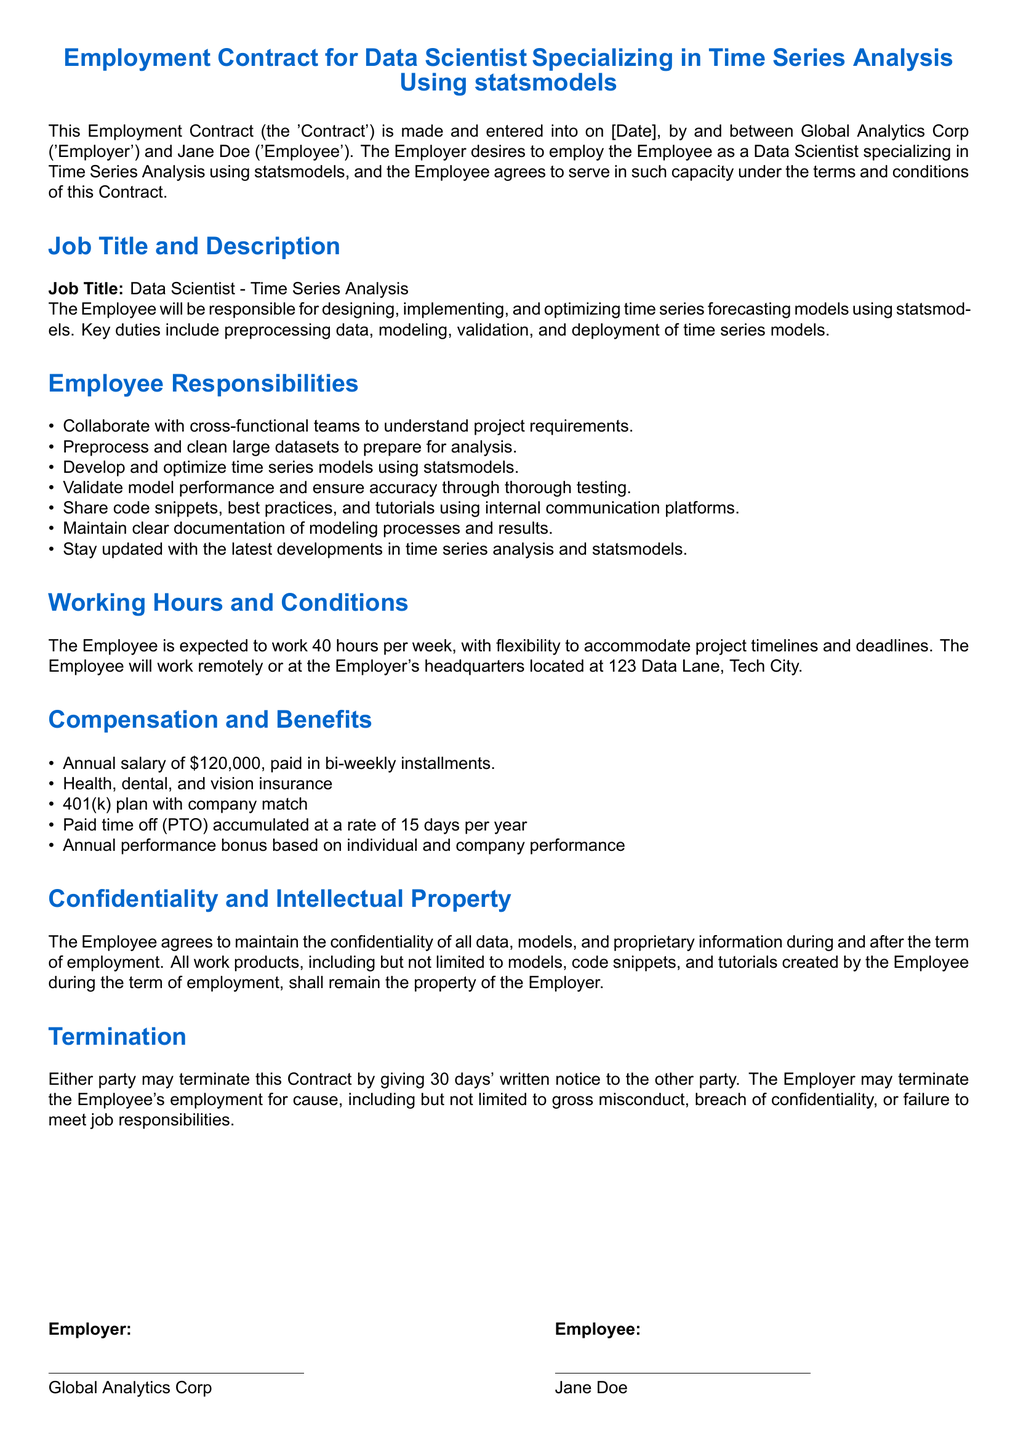What is the job title? The job title mentioned in the document is the specific position the Employee is being hired for, which is Data Scientist - Time Series Analysis.
Answer: Data Scientist - Time Series Analysis What is the annual salary? The annual salary is explicitly stated in the document as part of the compensation and benefits section.
Answer: $120,000 What are the expected working hours per week? This information can be found under the working hours and conditions section where it defines the Employee's expected work schedule.
Answer: 40 hours What is the notice period for termination? The termination section outlines the notice period required for either party to end the contract.
Answer: 30 days What type of insurance is provided? The compensation and benefits section lists various benefits, including health, dental, and vision insurance, as part of the offered package.
Answer: Health, dental, and vision insurance Which software library is the Employee expected to specialize in? The document specifies that the Employee should specialize in a particular library related to time series analysis.
Answer: statsmodels What is a key responsibility of the Employee? The responsibilities section outlines various tasks, one of which involves developing time series models.
Answer: Develop and optimize time series models What benefits accumulate at a rate of 15 days per year? This detail is presented in the compensation and benefits section regarding time off entitlement for the Employee.
Answer: Paid time off (PTO) What happens to the work products created by the Employee? The confidentiality and intellectual property section clarifies the ownership of the work products produced during employment.
Answer: Remain the property of the Employer 